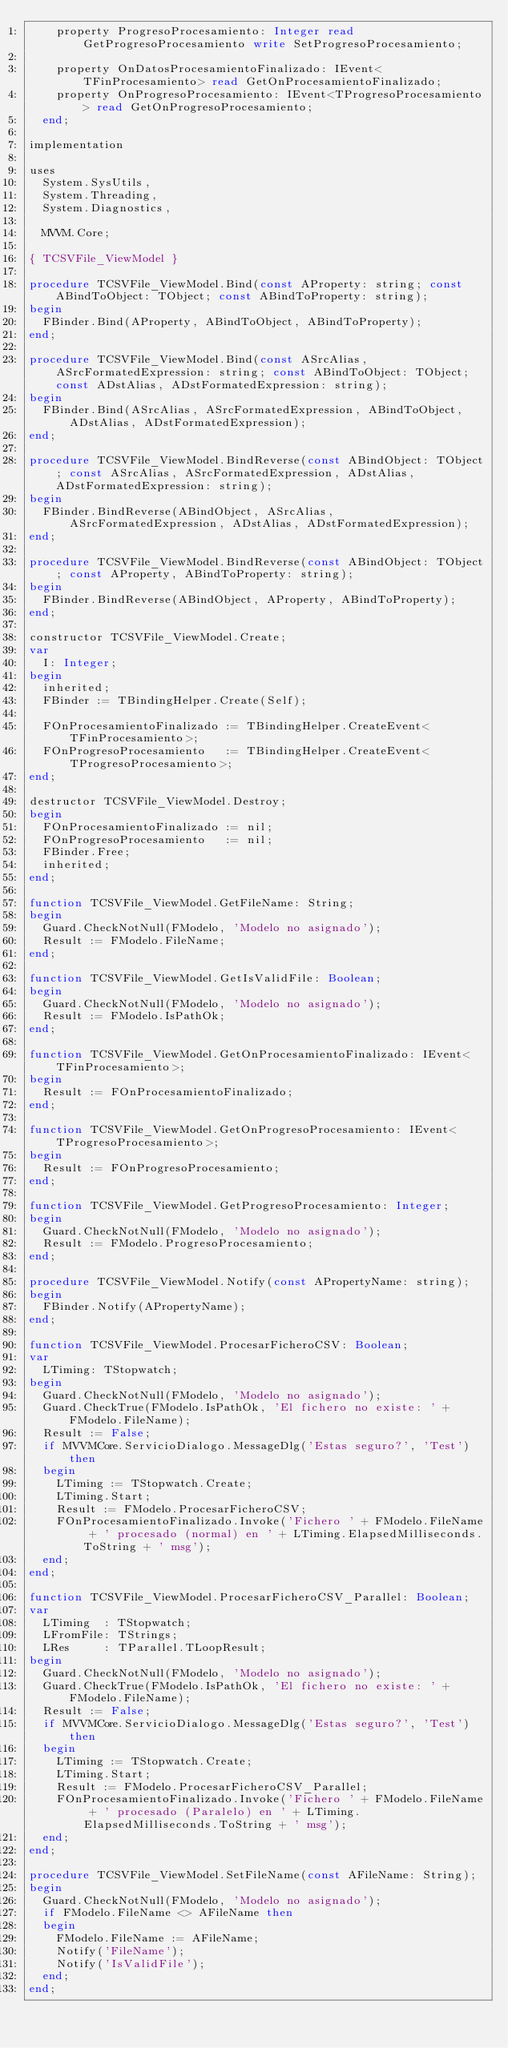Convert code to text. <code><loc_0><loc_0><loc_500><loc_500><_Pascal_>    property ProgresoProcesamiento: Integer read GetProgresoProcesamiento write SetProgresoProcesamiento;

    property OnDatosProcesamientoFinalizado: IEvent<TFinProcesamiento> read GetOnProcesamientoFinalizado;
    property OnProgresoProcesamiento: IEvent<TProgresoProcesamiento> read GetOnProgresoProcesamiento;
  end;

implementation

uses
  System.SysUtils,
  System.Threading,
  System.Diagnostics,

  MVVM.Core;

{ TCSVFile_ViewModel }

procedure TCSVFile_ViewModel.Bind(const AProperty: string; const ABindToObject: TObject; const ABindToProperty: string);
begin
  FBinder.Bind(AProperty, ABindToObject, ABindToProperty);
end;

procedure TCSVFile_ViewModel.Bind(const ASrcAlias, ASrcFormatedExpression: string; const ABindToObject: TObject; const ADstAlias, ADstFormatedExpression: string);
begin
  FBinder.Bind(ASrcAlias, ASrcFormatedExpression, ABindToObject, ADstAlias, ADstFormatedExpression);
end;

procedure TCSVFile_ViewModel.BindReverse(const ABindObject: TObject; const ASrcAlias, ASrcFormatedExpression, ADstAlias, ADstFormatedExpression: string);
begin
  FBinder.BindReverse(ABindObject, ASrcAlias, ASrcFormatedExpression, ADstAlias, ADstFormatedExpression);
end;

procedure TCSVFile_ViewModel.BindReverse(const ABindObject: TObject; const AProperty, ABindToProperty: string);
begin
  FBinder.BindReverse(ABindObject, AProperty, ABindToProperty);
end;

constructor TCSVFile_ViewModel.Create;
var
  I: Integer;
begin
  inherited;
  FBinder := TBindingHelper.Create(Self);

  FOnProcesamientoFinalizado := TBindingHelper.CreateEvent<TFinProcesamiento>;
  FOnProgresoProcesamiento   := TBindingHelper.CreateEvent<TProgresoProcesamiento>;
end;

destructor TCSVFile_ViewModel.Destroy;
begin
  FOnProcesamientoFinalizado := nil;
  FOnProgresoProcesamiento   := nil;
  FBinder.Free;
  inherited;
end;

function TCSVFile_ViewModel.GetFileName: String;
begin
  Guard.CheckNotNull(FModelo, 'Modelo no asignado');
  Result := FModelo.FileName;
end;

function TCSVFile_ViewModel.GetIsValidFile: Boolean;
begin
  Guard.CheckNotNull(FModelo, 'Modelo no asignado');
  Result := FModelo.IsPathOk;
end;

function TCSVFile_ViewModel.GetOnProcesamientoFinalizado: IEvent<TFinProcesamiento>;
begin
  Result := FOnProcesamientoFinalizado;
end;

function TCSVFile_ViewModel.GetOnProgresoProcesamiento: IEvent<TProgresoProcesamiento>;
begin
  Result := FOnProgresoProcesamiento;
end;

function TCSVFile_ViewModel.GetProgresoProcesamiento: Integer;
begin
  Guard.CheckNotNull(FModelo, 'Modelo no asignado');
  Result := FModelo.ProgresoProcesamiento;
end;

procedure TCSVFile_ViewModel.Notify(const APropertyName: string);
begin
  FBinder.Notify(APropertyName);
end;

function TCSVFile_ViewModel.ProcesarFicheroCSV: Boolean;
var
  LTiming: TStopwatch;
begin
  Guard.CheckNotNull(FModelo, 'Modelo no asignado');
  Guard.CheckTrue(FModelo.IsPathOk, 'El fichero no existe: ' + FModelo.FileName);
  Result := False;
  if MVVMCore.ServicioDialogo.MessageDlg('Estas seguro?', 'Test') then
  begin
    LTiming := TStopwatch.Create;
    LTiming.Start;
    Result := FModelo.ProcesarFicheroCSV;
    FOnProcesamientoFinalizado.Invoke('Fichero ' + FModelo.FileName + ' procesado (normal) en ' + LTiming.ElapsedMilliseconds.ToString + ' msg');
  end;
end;

function TCSVFile_ViewModel.ProcesarFicheroCSV_Parallel: Boolean;
var
  LTiming  : TStopwatch;
  LFromFile: TStrings;
  LRes     : TParallel.TLoopResult;
begin
  Guard.CheckNotNull(FModelo, 'Modelo no asignado');
  Guard.CheckTrue(FModelo.IsPathOk, 'El fichero no existe: ' + FModelo.FileName);
  Result := False;
  if MVVMCore.ServicioDialogo.MessageDlg('Estas seguro?', 'Test') then
  begin
    LTiming := TStopwatch.Create;
    LTiming.Start;
    Result := FModelo.ProcesarFicheroCSV_Parallel;
    FOnProcesamientoFinalizado.Invoke('Fichero ' + FModelo.FileName + ' procesado (Paralelo) en ' + LTiming.ElapsedMilliseconds.ToString + ' msg');
  end;
end;

procedure TCSVFile_ViewModel.SetFileName(const AFileName: String);
begin
  Guard.CheckNotNull(FModelo, 'Modelo no asignado');
  if FModelo.FileName <> AFileName then
  begin
    FModelo.FileName := AFileName;
    Notify('FileName');
    Notify('IsValidFile');
  end;
end;
</code> 